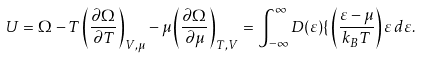<formula> <loc_0><loc_0><loc_500><loc_500>U = \Omega - T \left ( { \frac { \partial \Omega } { \partial T } } \right ) _ { V , \mu } - \mu \left ( { \frac { \partial \Omega } { \partial \mu } } \right ) _ { T , V } = \int _ { - \infty } ^ { \infty } D ( \varepsilon ) { \mathcal { f } } \left ( { \frac { \varepsilon - \mu } { k _ { B } T } } \right ) \varepsilon \, d \varepsilon .</formula> 